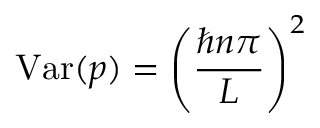Convert formula to latex. <formula><loc_0><loc_0><loc_500><loc_500>V a r ( p ) = \left ( { \frac { \hbar { n } \pi } { L } } \right ) ^ { 2 }</formula> 